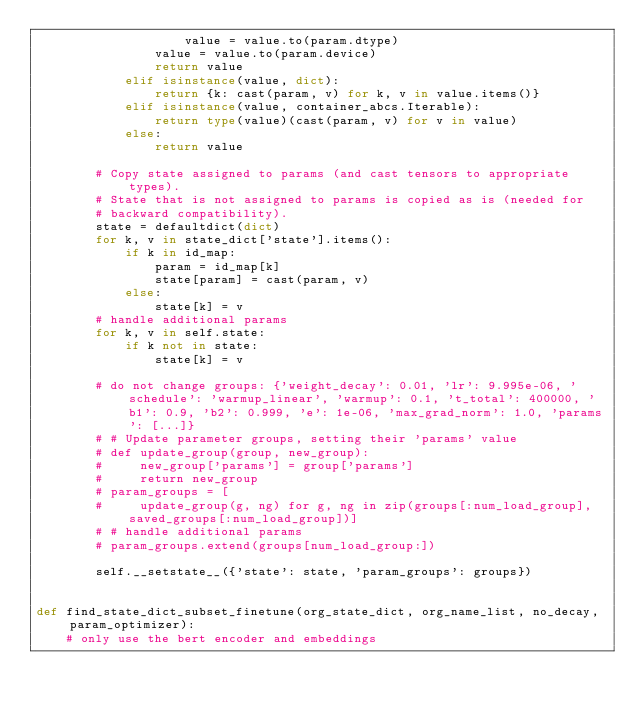Convert code to text. <code><loc_0><loc_0><loc_500><loc_500><_Python_>                    value = value.to(param.dtype)
                value = value.to(param.device)
                return value
            elif isinstance(value, dict):
                return {k: cast(param, v) for k, v in value.items()}
            elif isinstance(value, container_abcs.Iterable):
                return type(value)(cast(param, v) for v in value)
            else:
                return value

        # Copy state assigned to params (and cast tensors to appropriate types).
        # State that is not assigned to params is copied as is (needed for
        # backward compatibility).
        state = defaultdict(dict)
        for k, v in state_dict['state'].items():
            if k in id_map:
                param = id_map[k]
                state[param] = cast(param, v)
            else:
                state[k] = v
        # handle additional params
        for k, v in self.state:
            if k not in state:
                state[k] = v

        # do not change groups: {'weight_decay': 0.01, 'lr': 9.995e-06, 'schedule': 'warmup_linear', 'warmup': 0.1, 't_total': 400000, 'b1': 0.9, 'b2': 0.999, 'e': 1e-06, 'max_grad_norm': 1.0, 'params': [...]}
        # # Update parameter groups, setting their 'params' value
        # def update_group(group, new_group):
        #     new_group['params'] = group['params']
        #     return new_group
        # param_groups = [
        #     update_group(g, ng) for g, ng in zip(groups[:num_load_group], saved_groups[:num_load_group])]
        # # handle additional params
        # param_groups.extend(groups[num_load_group:])

        self.__setstate__({'state': state, 'param_groups': groups})


def find_state_dict_subset_finetune(org_state_dict, org_name_list, no_decay, param_optimizer):
    # only use the bert encoder and embeddings</code> 